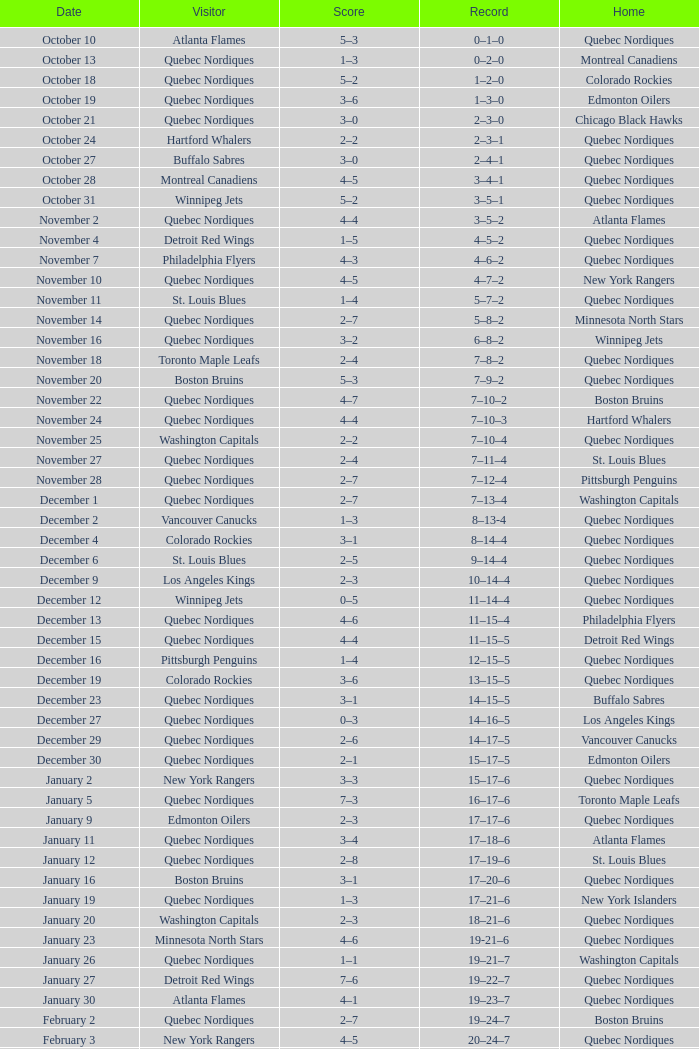Which Record has a Home of edmonton oilers, and a Score of 3–6? 1–3–0. 